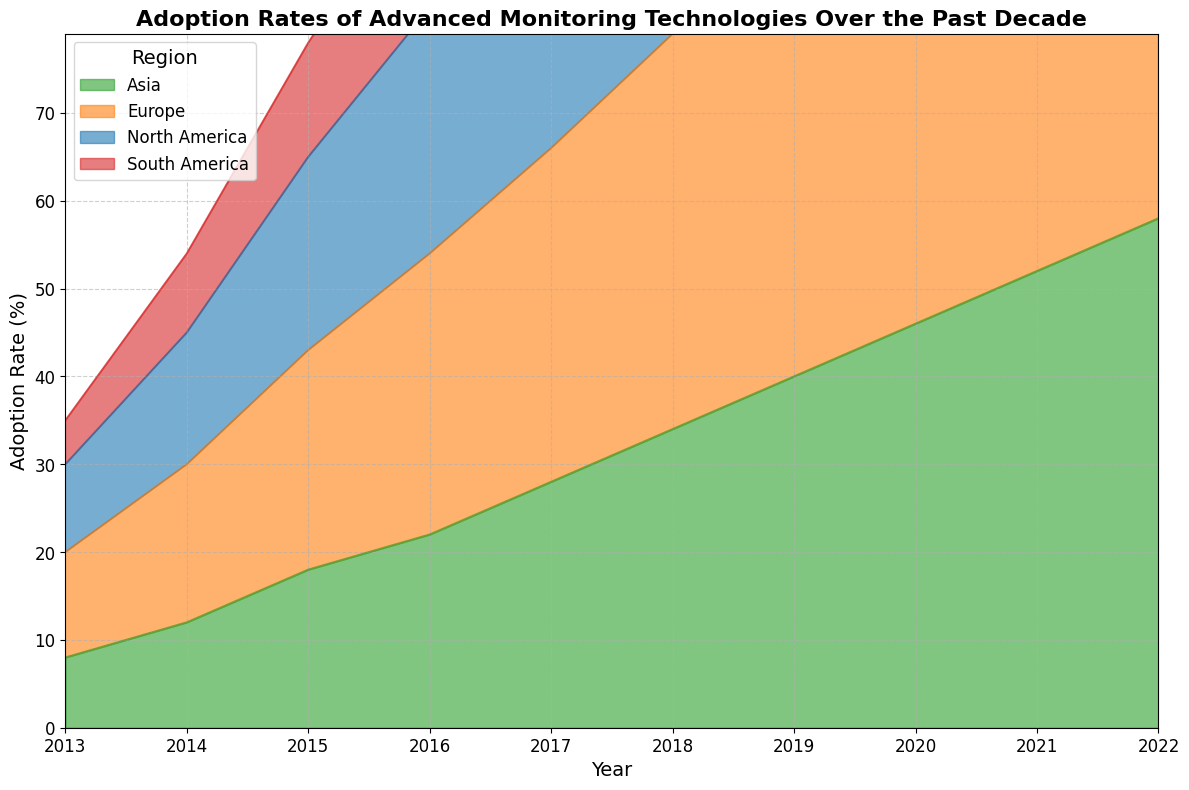What is the adoption rate percentage of advanced monitoring technologies in Europe in 2019? To find the adoption rate percentage in Europe for 2019, locate the year 2019 on the x-axis and then track vertically to see where it intersects with the Europe (orange) area.
Answer: 52% Which region had the lowest adoption rate percentage in 2013, and what was the percentage? Compare the adoption rate percentages of all regions for 2013 by examining the height of the colored areas at the 2013 mark on the x-axis. South America (red) has the smallest height.
Answer: South America, 5% How did the adoption rate in Asia change from 2013 to 2022? To determine the change, look at the difference in heights of the green area (Asia) from 2013 to 2022. In 2013, the rate is 8%, and in 2022, it is 58%. Subtract the initial rate from the final rate: 58% - 8%.
Answer: Increased by 50% In which year did North America surpass a 50% adoption rate, and what was the exact percentage that year? Find the point where North America's (blue) area exceeds half the y-axis. The rate first exceeds 50% in 2020.
Answer: 2020, 52% By how much did adoption rates in South America increase between 2018 and 2021? Identify the adoption rate percentages in 2018 and 2021 for South America (red): 26% in 2018 and 41% in 2021. Subtract the two values: 41% - 26%.
Answer: 15% Which region had the highest adoption rate percentage increase over the decade, and what was the amount of increase? Estimate the differences between adoption rates for each region by comparing the starting and ending heights of the colored areas. Europe (orange) went from 12% in 2013 to 69% in 2022. Subtract the initial value from the final value: 69% - 12%.
Answer: Europe, 57% In 2020, how did the adoption rate of Asia compare to North America? Compare the heights of the green (Asia) and blue (North America) areas in 2020. Asia is at 46%, and North America is at 52%. Subtract the lower value from the higher value to find the difference.
Answer: 6% lower Which two regions have the most similar adoption rates in 2016, and what is the percentage difference between them? Compare the heights of the colored areas for each region in 2016. North America and Europe (blue and orange) have rates of 28% and 32%, respectively. Subtract the smaller percentage from the larger one: 32% - 28%.
Answer: North America and Europe, 4% What was the overall trend in the adoption rate of advanced monitoring technologies in North America over the past decade? Observe the trajectory of the blue area for North America from 2013 to 2022. The adoption rate starts at 10% and steadily increases to 64%.
Answer: Increasing trend How much higher was Europe’s adoption rate compared to Asia’s in 2022? Look at the adoption rates in 2022 for Europe (orange) and Asia (green). Europe is at 69%, and Asia is at 58%. Subtract the Asia rate from the Europe rate to get the difference.
Answer: 11% higher 